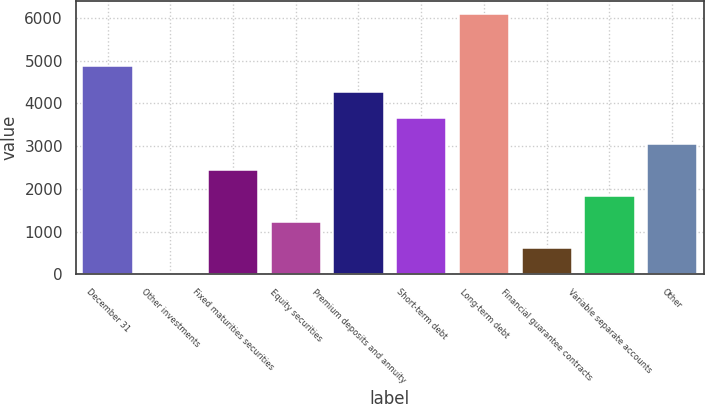<chart> <loc_0><loc_0><loc_500><loc_500><bar_chart><fcel>December 31<fcel>Other investments<fcel>Fixed maturities securities<fcel>Equity securities<fcel>Premium deposits and annuity<fcel>Short-term debt<fcel>Long-term debt<fcel>Financial guarantee contracts<fcel>Variable separate accounts<fcel>Other<nl><fcel>4874.56<fcel>8<fcel>2441.28<fcel>1224.64<fcel>4266.24<fcel>3657.92<fcel>6091.2<fcel>616.32<fcel>1832.96<fcel>3049.6<nl></chart> 